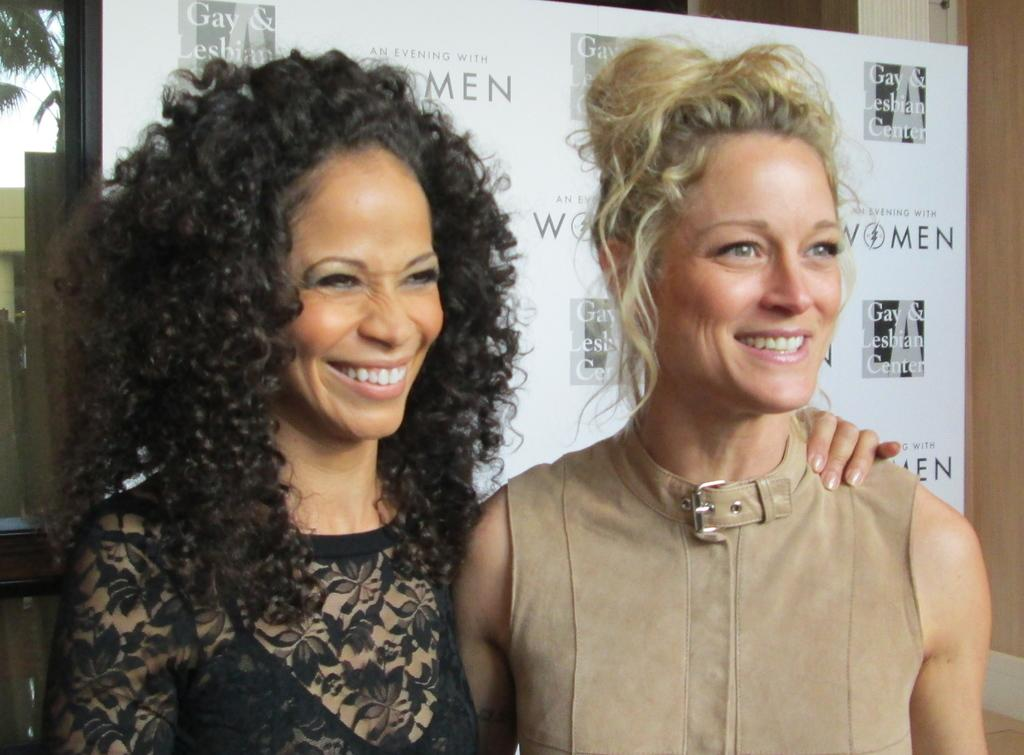How many people are in the image? There are two women in the image. What is the facial expression of the women? The women are smiling. What can be seen on the banner in the image? There is a banner with text in the image. What type of architectural feature is present in the image? There is a glass window in the image. What type of bomb can be seen exploding near the women in the image? There is no bomb or explosion present in the image; the women are simply smiling. How does the ray of light affect the women in the image? There is no ray of light mentioned in the provided facts, so we cannot answer this question. 